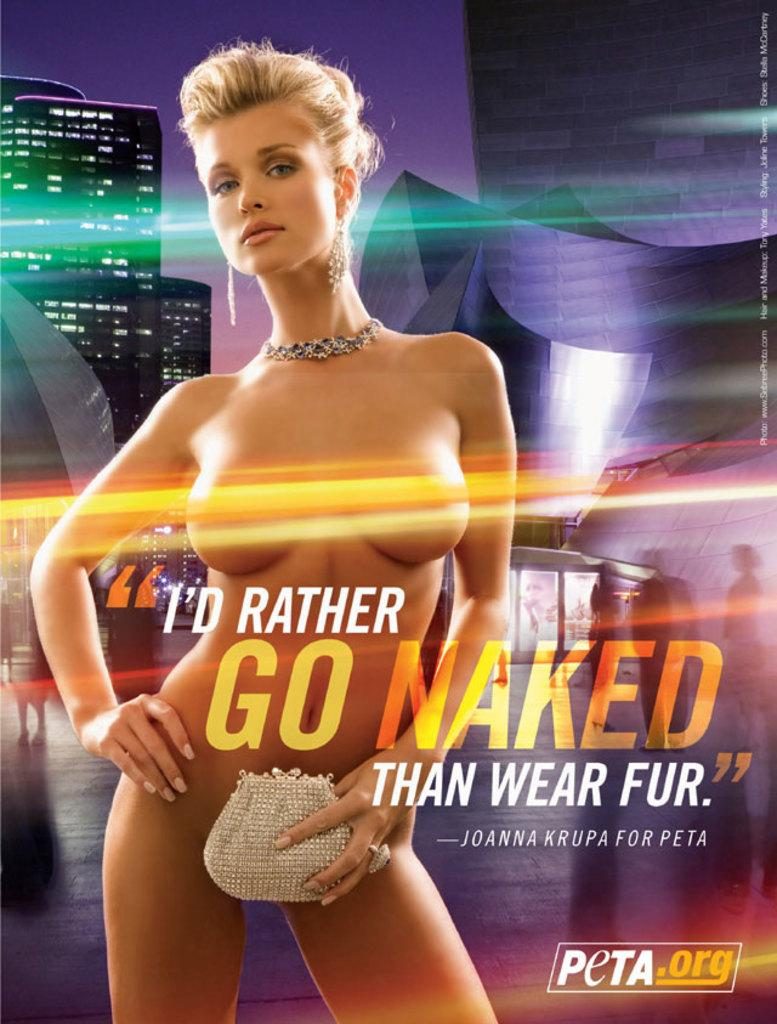<image>
Provide a brief description of the given image. poster of a naked women for the Peta.org 